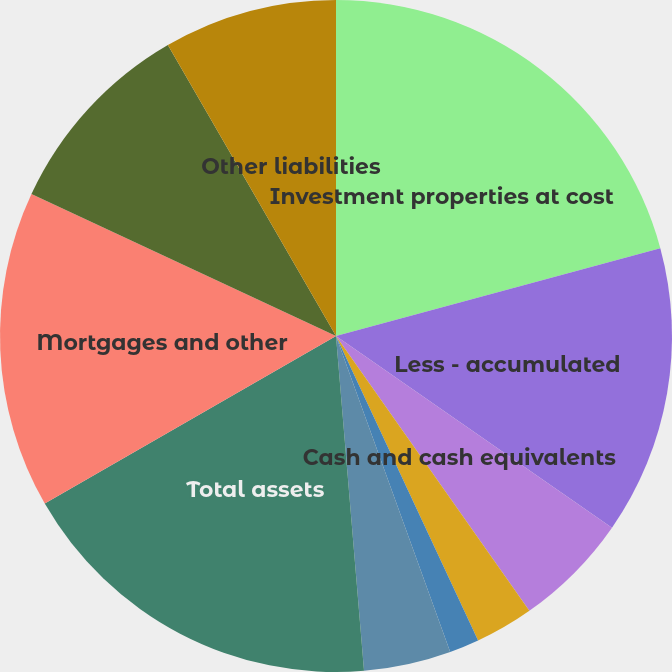<chart> <loc_0><loc_0><loc_500><loc_500><pie_chart><fcel>Investment properties at cost<fcel>Less - accumulated<fcel>Cash and cash equivalents<fcel>Tenant receivables and accrued<fcel>Investment in unconsolidated<fcel>Deferred costs and other<fcel>Total assets<fcel>Mortgages and other<fcel>Accounts payable accrued<fcel>Other liabilities<nl><fcel>20.79%<fcel>13.87%<fcel>5.58%<fcel>2.81%<fcel>1.43%<fcel>4.19%<fcel>18.02%<fcel>15.25%<fcel>9.72%<fcel>8.34%<nl></chart> 